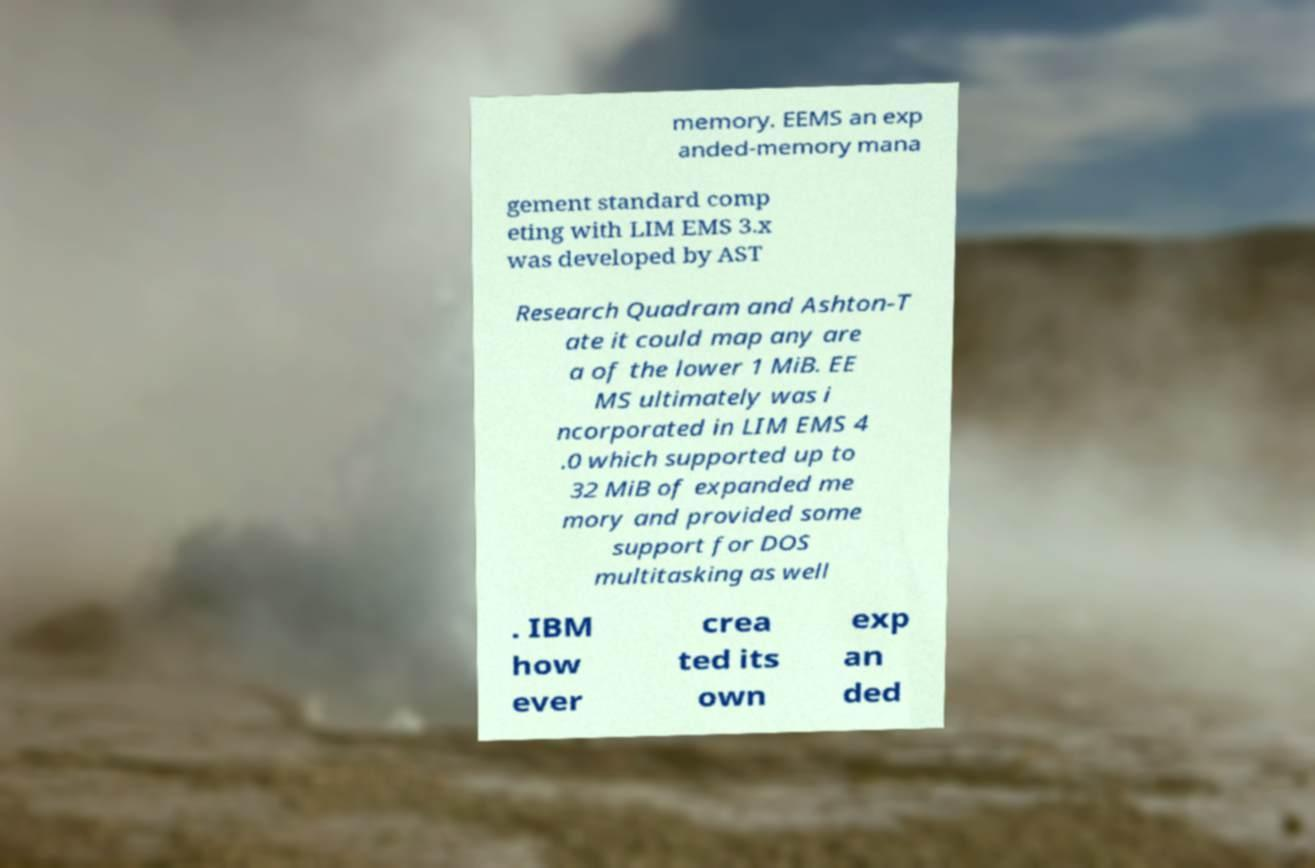There's text embedded in this image that I need extracted. Can you transcribe it verbatim? memory. EEMS an exp anded-memory mana gement standard comp eting with LIM EMS 3.x was developed by AST Research Quadram and Ashton-T ate it could map any are a of the lower 1 MiB. EE MS ultimately was i ncorporated in LIM EMS 4 .0 which supported up to 32 MiB of expanded me mory and provided some support for DOS multitasking as well . IBM how ever crea ted its own exp an ded 